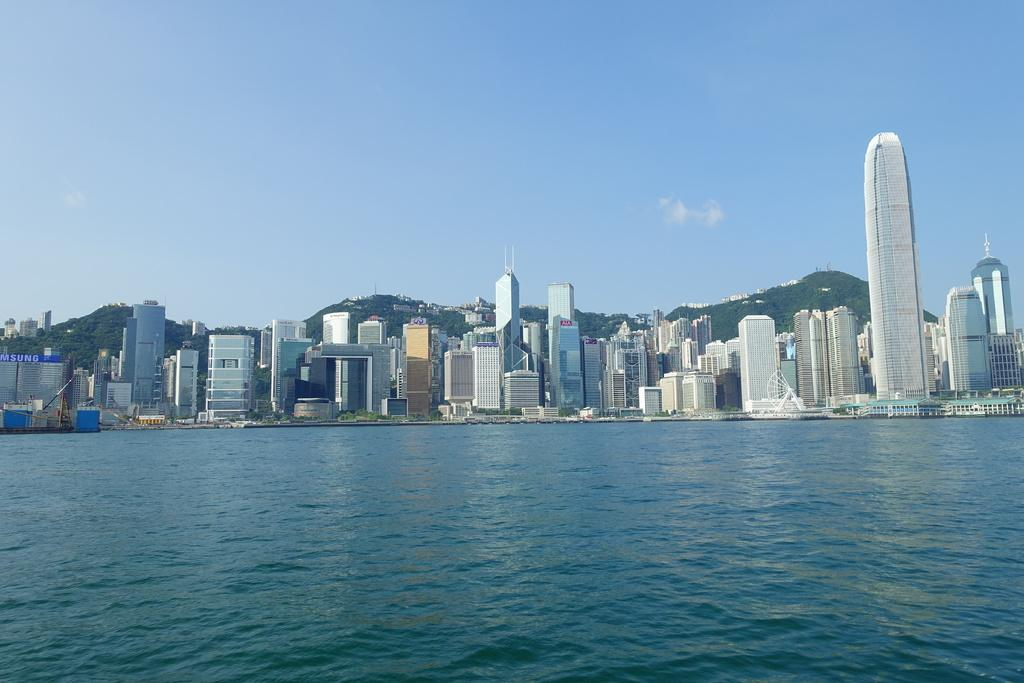What is the primary element visible in the image? There is water in the image. What type of structures can be seen in the background of the image? There are buildings and skyscrapers in the background of the image. What natural feature is visible in the background of the image? There are mountains in the background of the image. What is visible at the top of the image? The sky is visible at the top of the image. How much sugar is in the pancake in the image? There is no pancake present in the image, so it is not possible to determine the amount of sugar in it. 